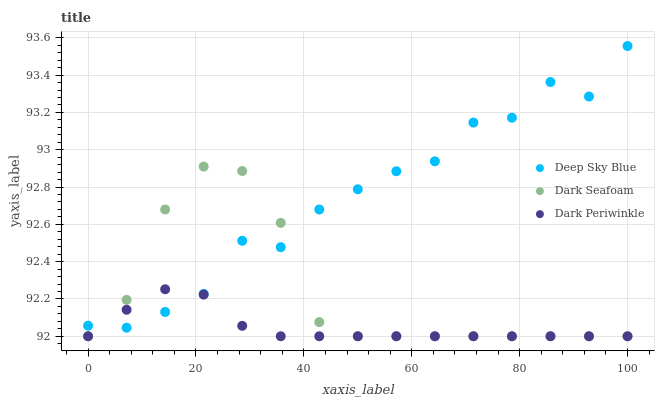Does Dark Periwinkle have the minimum area under the curve?
Answer yes or no. Yes. Does Deep Sky Blue have the maximum area under the curve?
Answer yes or no. Yes. Does Deep Sky Blue have the minimum area under the curve?
Answer yes or no. No. Does Dark Periwinkle have the maximum area under the curve?
Answer yes or no. No. Is Dark Periwinkle the smoothest?
Answer yes or no. Yes. Is Deep Sky Blue the roughest?
Answer yes or no. Yes. Is Deep Sky Blue the smoothest?
Answer yes or no. No. Is Dark Periwinkle the roughest?
Answer yes or no. No. Does Dark Seafoam have the lowest value?
Answer yes or no. Yes. Does Deep Sky Blue have the lowest value?
Answer yes or no. No. Does Deep Sky Blue have the highest value?
Answer yes or no. Yes. Does Dark Periwinkle have the highest value?
Answer yes or no. No. Does Deep Sky Blue intersect Dark Periwinkle?
Answer yes or no. Yes. Is Deep Sky Blue less than Dark Periwinkle?
Answer yes or no. No. Is Deep Sky Blue greater than Dark Periwinkle?
Answer yes or no. No. 